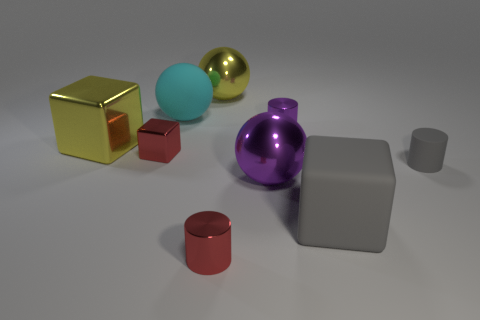The big sphere that is the same material as the big gray thing is what color?
Provide a succinct answer. Cyan. There is a red object that is on the right side of the cyan matte object; is it the same size as the cyan ball?
Provide a succinct answer. No. Are the yellow block and the big cube that is to the right of the tiny cube made of the same material?
Your response must be concise. No. There is a thing behind the large rubber ball; what color is it?
Offer a very short reply. Yellow. There is a cyan matte ball behind the yellow shiny block; is there a red thing that is behind it?
Ensure brevity in your answer.  No. Does the big rubber object that is behind the large gray thing have the same color as the shiny cylinder that is on the right side of the purple metallic ball?
Offer a very short reply. No. There is a small purple metallic thing; how many balls are behind it?
Give a very brief answer. 2. What number of rubber objects have the same color as the matte cylinder?
Your answer should be very brief. 1. Do the gray thing that is behind the large purple metal object and the cyan thing have the same material?
Your answer should be compact. Yes. How many tiny blocks are the same material as the purple ball?
Offer a terse response. 1. 